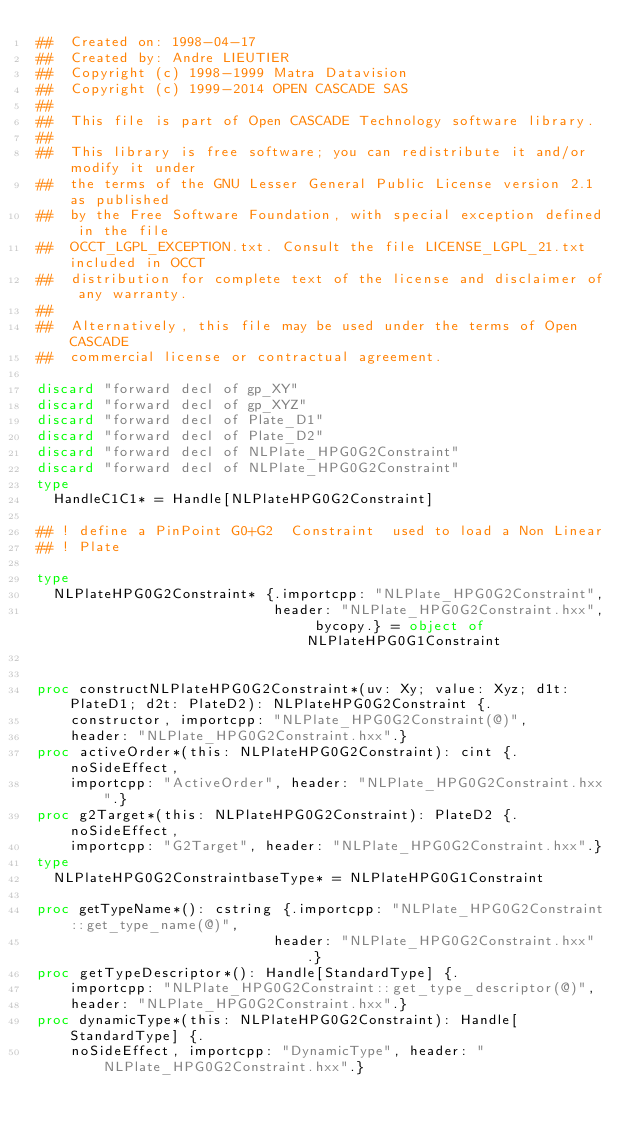<code> <loc_0><loc_0><loc_500><loc_500><_Nim_>##  Created on: 1998-04-17
##  Created by: Andre LIEUTIER
##  Copyright (c) 1998-1999 Matra Datavision
##  Copyright (c) 1999-2014 OPEN CASCADE SAS
##
##  This file is part of Open CASCADE Technology software library.
##
##  This library is free software; you can redistribute it and/or modify it under
##  the terms of the GNU Lesser General Public License version 2.1 as published
##  by the Free Software Foundation, with special exception defined in the file
##  OCCT_LGPL_EXCEPTION.txt. Consult the file LICENSE_LGPL_21.txt included in OCCT
##  distribution for complete text of the license and disclaimer of any warranty.
##
##  Alternatively, this file may be used under the terms of Open CASCADE
##  commercial license or contractual agreement.

discard "forward decl of gp_XY"
discard "forward decl of gp_XYZ"
discard "forward decl of Plate_D1"
discard "forward decl of Plate_D2"
discard "forward decl of NLPlate_HPG0G2Constraint"
discard "forward decl of NLPlate_HPG0G2Constraint"
type
  HandleC1C1* = Handle[NLPlateHPG0G2Constraint]

## ! define a PinPoint G0+G2  Constraint  used to load a Non Linear
## ! Plate

type
  NLPlateHPG0G2Constraint* {.importcpp: "NLPlate_HPG0G2Constraint",
                            header: "NLPlate_HPG0G2Constraint.hxx", bycopy.} = object of NLPlateHPG0G1Constraint


proc constructNLPlateHPG0G2Constraint*(uv: Xy; value: Xyz; d1t: PlateD1; d2t: PlateD2): NLPlateHPG0G2Constraint {.
    constructor, importcpp: "NLPlate_HPG0G2Constraint(@)",
    header: "NLPlate_HPG0G2Constraint.hxx".}
proc activeOrder*(this: NLPlateHPG0G2Constraint): cint {.noSideEffect,
    importcpp: "ActiveOrder", header: "NLPlate_HPG0G2Constraint.hxx".}
proc g2Target*(this: NLPlateHPG0G2Constraint): PlateD2 {.noSideEffect,
    importcpp: "G2Target", header: "NLPlate_HPG0G2Constraint.hxx".}
type
  NLPlateHPG0G2ConstraintbaseType* = NLPlateHPG0G1Constraint

proc getTypeName*(): cstring {.importcpp: "NLPlate_HPG0G2Constraint::get_type_name(@)",
                            header: "NLPlate_HPG0G2Constraint.hxx".}
proc getTypeDescriptor*(): Handle[StandardType] {.
    importcpp: "NLPlate_HPG0G2Constraint::get_type_descriptor(@)",
    header: "NLPlate_HPG0G2Constraint.hxx".}
proc dynamicType*(this: NLPlateHPG0G2Constraint): Handle[StandardType] {.
    noSideEffect, importcpp: "DynamicType", header: "NLPlate_HPG0G2Constraint.hxx".}

























</code> 